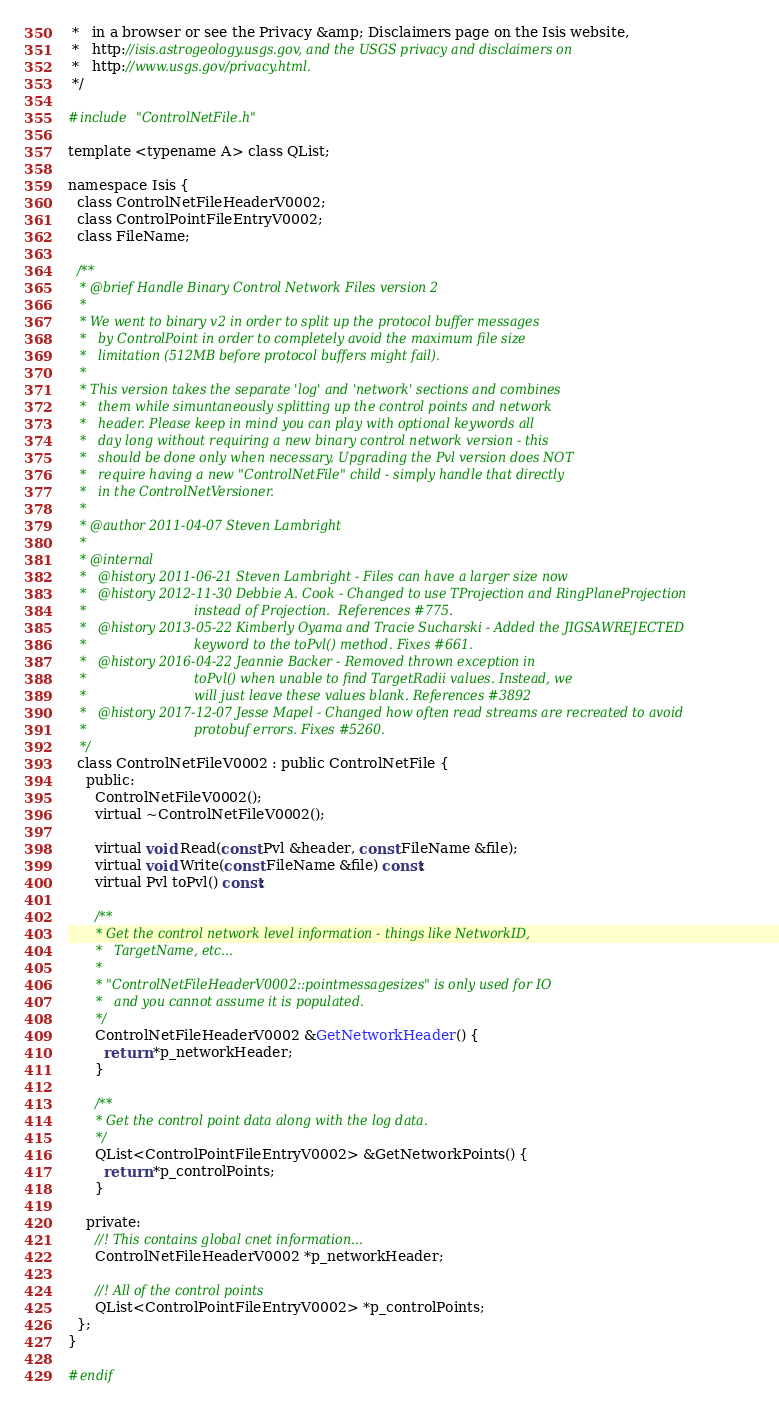<code> <loc_0><loc_0><loc_500><loc_500><_C_> *   in a browser or see the Privacy &amp; Disclaimers page on the Isis website,
 *   http://isis.astrogeology.usgs.gov, and the USGS privacy and disclaimers on
 *   http://www.usgs.gov/privacy.html.
 */

#include "ControlNetFile.h"

template <typename A> class QList;

namespace Isis {
  class ControlNetFileHeaderV0002;
  class ControlPointFileEntryV0002;
  class FileName;

  /**
   * @brief Handle Binary Control Network Files version 2
   *
   * We went to binary v2 in order to split up the protocol buffer messages
   *   by ControlPoint in order to completely avoid the maximum file size
   *   limitation (512MB before protocol buffers might fail).
   *
   * This version takes the separate 'log' and 'network' sections and combines
   *   them while simuntaneously splitting up the control points and network
   *   header. Please keep in mind you can play with optional keywords all
   *   day long without requiring a new binary control network version - this
   *   should be done only when necessary. Upgrading the Pvl version does NOT
   *   require having a new "ControlNetFile" child - simply handle that directly
   *   in the ControlNetVersioner.
   *
   * @author 2011-04-07 Steven Lambright
   *
   * @internal
   *   @history 2011-06-21 Steven Lambright - Files can have a larger size now
   *   @history 2012-11-30 Debbie A. Cook - Changed to use TProjection and RingPlaneProjection
   *                           instead of Projection.  References #775.
   *   @history 2013-05-22 Kimberly Oyama and Tracie Sucharski - Added the JIGSAWREJECTED
   *                           keyword to the toPvl() method. Fixes #661.
   *   @history 2016-04-22 Jeannie Backer - Removed thrown exception in
   *                           toPvl() when unable to find TargetRadii values. Instead, we
   *                           will just leave these values blank. References #3892
   *   @history 2017-12-07 Jesse Mapel - Changed how often read streams are recreated to avoid
   *                           protobuf errors. Fixes #5260.
   */
  class ControlNetFileV0002 : public ControlNetFile {
    public:
      ControlNetFileV0002();
      virtual ~ControlNetFileV0002();

      virtual void Read(const Pvl &header, const FileName &file);
      virtual void Write(const FileName &file) const;
      virtual Pvl toPvl() const;

      /**
       * Get the control network level information - things like NetworkID,
       *   TargetName, etc...
       *
       * "ControlNetFileHeaderV0002::pointmessagesizes" is only used for IO
       *   and you cannot assume it is populated.
       */
      ControlNetFileHeaderV0002 &GetNetworkHeader() {
        return *p_networkHeader;
      }

      /**
       * Get the control point data along with the log data.
       */
      QList<ControlPointFileEntryV0002> &GetNetworkPoints() {
        return *p_controlPoints;
      }

    private:
      //! This contains global cnet information...
      ControlNetFileHeaderV0002 *p_networkHeader;

      //! All of the control points
      QList<ControlPointFileEntryV0002> *p_controlPoints;
  };
}

#endif
</code> 